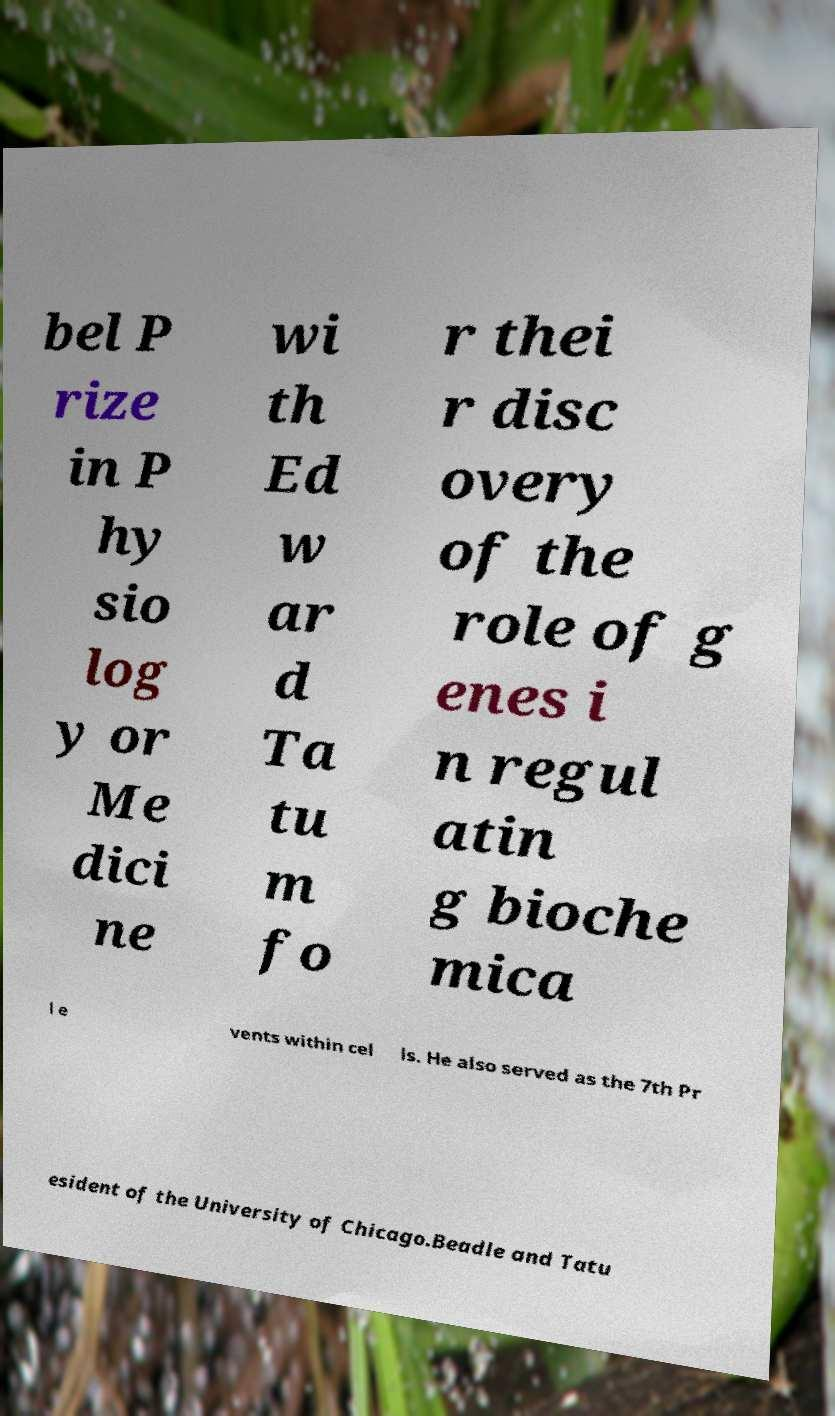There's text embedded in this image that I need extracted. Can you transcribe it verbatim? bel P rize in P hy sio log y or Me dici ne wi th Ed w ar d Ta tu m fo r thei r disc overy of the role of g enes i n regul atin g bioche mica l e vents within cel ls. He also served as the 7th Pr esident of the University of Chicago.Beadle and Tatu 